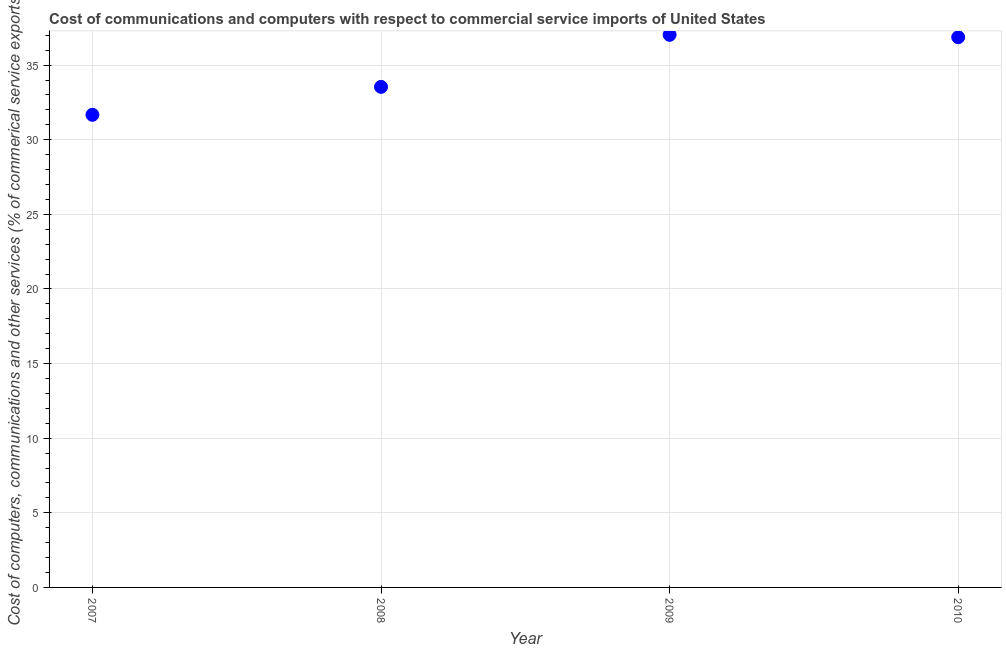What is the cost of communications in 2009?
Offer a very short reply. 37.03. Across all years, what is the maximum  computer and other services?
Provide a succinct answer. 37.03. Across all years, what is the minimum  computer and other services?
Offer a terse response. 31.67. In which year was the  computer and other services maximum?
Provide a succinct answer. 2009. In which year was the  computer and other services minimum?
Your response must be concise. 2007. What is the sum of the  computer and other services?
Ensure brevity in your answer.  139.1. What is the difference between the cost of communications in 2008 and 2010?
Your answer should be very brief. -3.33. What is the average  computer and other services per year?
Your answer should be very brief. 34.78. What is the median cost of communications?
Your answer should be very brief. 35.2. Do a majority of the years between 2010 and 2008 (inclusive) have cost of communications greater than 20 %?
Ensure brevity in your answer.  No. What is the ratio of the cost of communications in 2009 to that in 2010?
Make the answer very short. 1. Is the cost of communications in 2007 less than that in 2009?
Offer a terse response. Yes. Is the difference between the cost of communications in 2007 and 2008 greater than the difference between any two years?
Your answer should be compact. No. What is the difference between the highest and the second highest  computer and other services?
Give a very brief answer. 0.16. What is the difference between the highest and the lowest cost of communications?
Offer a very short reply. 5.36. In how many years, is the  computer and other services greater than the average  computer and other services taken over all years?
Provide a short and direct response. 2. How many years are there in the graph?
Provide a short and direct response. 4. What is the difference between two consecutive major ticks on the Y-axis?
Make the answer very short. 5. Are the values on the major ticks of Y-axis written in scientific E-notation?
Your response must be concise. No. What is the title of the graph?
Make the answer very short. Cost of communications and computers with respect to commercial service imports of United States. What is the label or title of the X-axis?
Give a very brief answer. Year. What is the label or title of the Y-axis?
Offer a terse response. Cost of computers, communications and other services (% of commerical service exports). What is the Cost of computers, communications and other services (% of commerical service exports) in 2007?
Your answer should be compact. 31.67. What is the Cost of computers, communications and other services (% of commerical service exports) in 2008?
Provide a short and direct response. 33.54. What is the Cost of computers, communications and other services (% of commerical service exports) in 2009?
Your answer should be compact. 37.03. What is the Cost of computers, communications and other services (% of commerical service exports) in 2010?
Give a very brief answer. 36.87. What is the difference between the Cost of computers, communications and other services (% of commerical service exports) in 2007 and 2008?
Keep it short and to the point. -1.87. What is the difference between the Cost of computers, communications and other services (% of commerical service exports) in 2007 and 2009?
Provide a short and direct response. -5.36. What is the difference between the Cost of computers, communications and other services (% of commerical service exports) in 2007 and 2010?
Offer a very short reply. -5.2. What is the difference between the Cost of computers, communications and other services (% of commerical service exports) in 2008 and 2009?
Offer a very short reply. -3.49. What is the difference between the Cost of computers, communications and other services (% of commerical service exports) in 2008 and 2010?
Provide a succinct answer. -3.33. What is the difference between the Cost of computers, communications and other services (% of commerical service exports) in 2009 and 2010?
Make the answer very short. 0.16. What is the ratio of the Cost of computers, communications and other services (% of commerical service exports) in 2007 to that in 2008?
Provide a short and direct response. 0.94. What is the ratio of the Cost of computers, communications and other services (% of commerical service exports) in 2007 to that in 2009?
Your response must be concise. 0.85. What is the ratio of the Cost of computers, communications and other services (% of commerical service exports) in 2007 to that in 2010?
Ensure brevity in your answer.  0.86. What is the ratio of the Cost of computers, communications and other services (% of commerical service exports) in 2008 to that in 2009?
Ensure brevity in your answer.  0.91. What is the ratio of the Cost of computers, communications and other services (% of commerical service exports) in 2008 to that in 2010?
Ensure brevity in your answer.  0.91. 